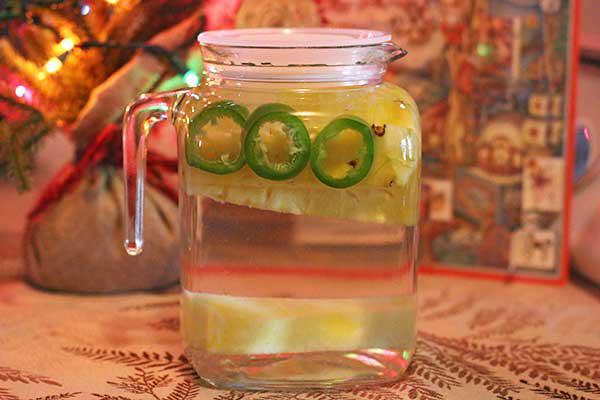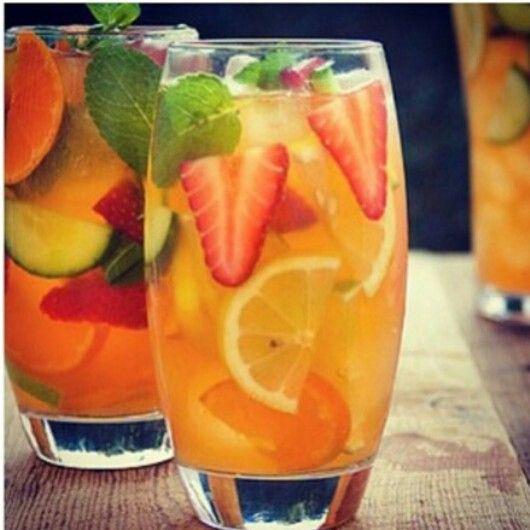The first image is the image on the left, the second image is the image on the right. Evaluate the accuracy of this statement regarding the images: "The right image shows four fruit-filled cylindrical jars arranged horizontally.". Is it true? Answer yes or no. No. 